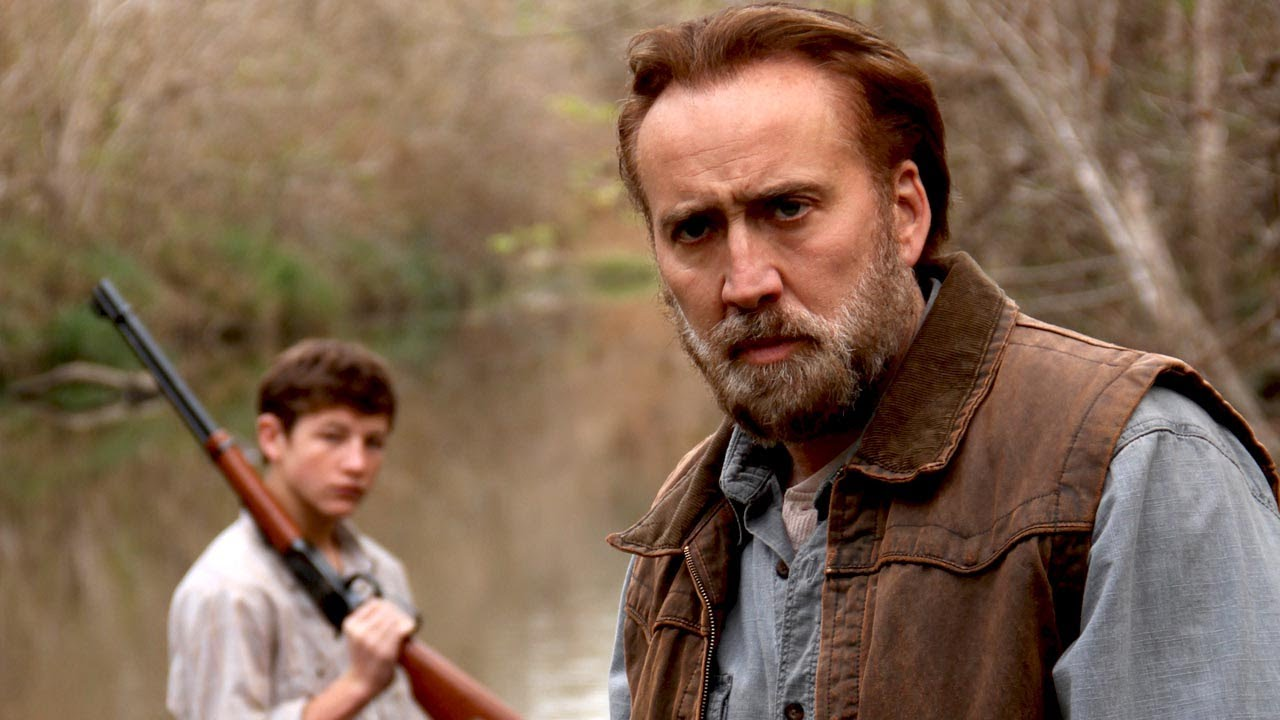What do you see happening in this image? In the image, two individuals are portrayed in a natural setting, seemingly preparing for or returning from a hunt. The older man in the foreground has a focused expression, wearing a rugged leather vest over a denim shirt, suggesting a role of leadership or experience. The boy behind him also carries a shotgun, looking towards the older man, perhaps seeking guidance or approval. This scene possibly depicts a father-son dynamic or a mentorship moment in a rural environment. 